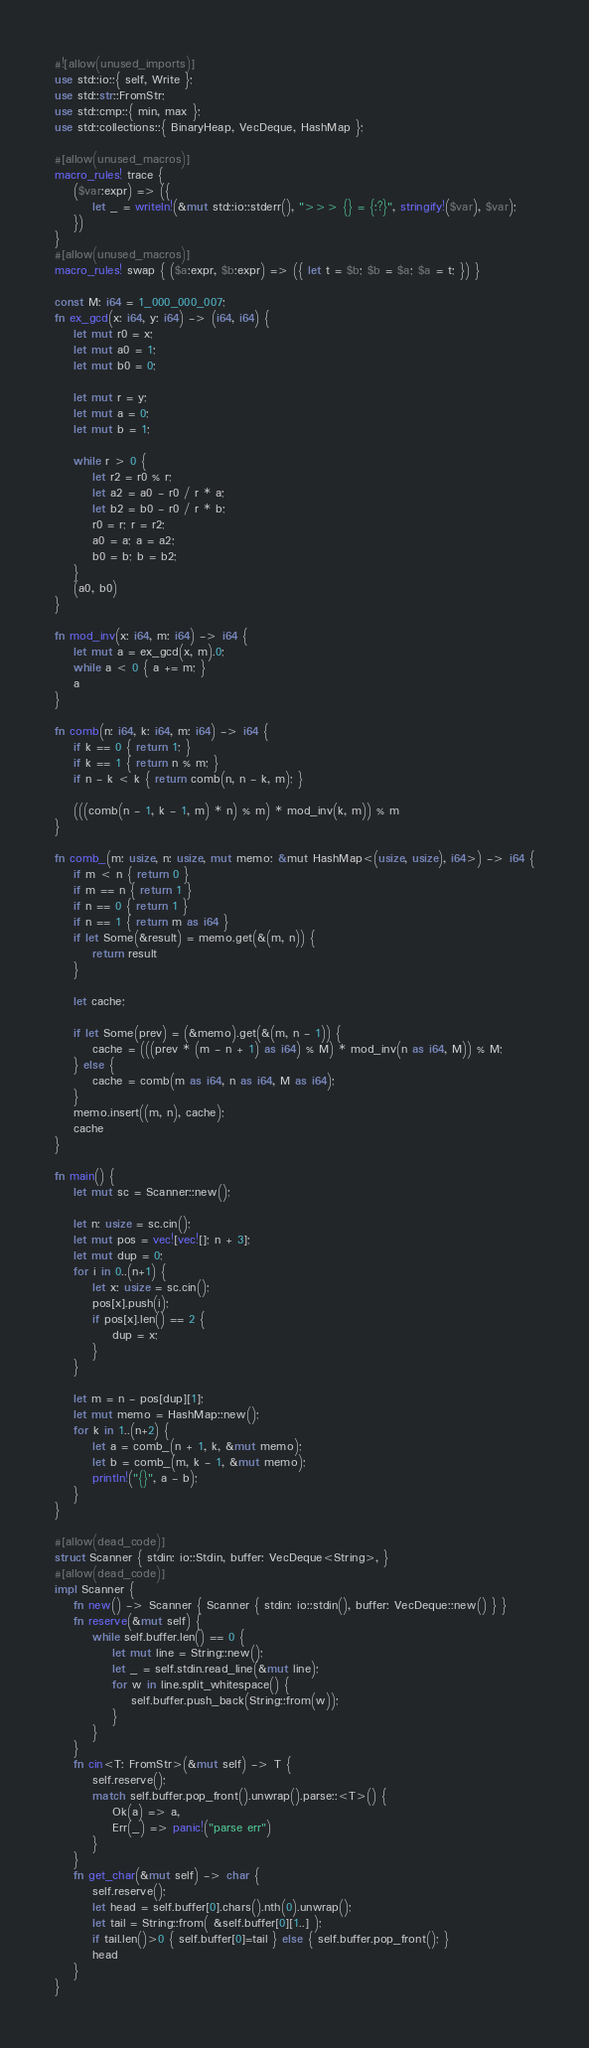Convert code to text. <code><loc_0><loc_0><loc_500><loc_500><_Rust_>#![allow(unused_imports)]
use std::io::{ self, Write };
use std::str::FromStr;
use std::cmp::{ min, max };
use std::collections::{ BinaryHeap, VecDeque, HashMap };

#[allow(unused_macros)]
macro_rules! trace {
    ($var:expr) => ({
        let _ = writeln!(&mut std::io::stderr(), ">>> {} = {:?}", stringify!($var), $var);
    })
}
#[allow(unused_macros)]
macro_rules! swap { ($a:expr, $b:expr) => ({ let t = $b; $b = $a; $a = t; }) }

const M: i64 = 1_000_000_007;
fn ex_gcd(x: i64, y: i64) -> (i64, i64) {
    let mut r0 = x;
    let mut a0 = 1;
    let mut b0 = 0;

    let mut r = y;
    let mut a = 0;
    let mut b = 1;

    while r > 0 {
        let r2 = r0 % r;
        let a2 = a0 - r0 / r * a;
        let b2 = b0 - r0 / r * b;
        r0 = r; r = r2;
        a0 = a; a = a2;
        b0 = b; b = b2;
    }
    (a0, b0)
}

fn mod_inv(x: i64, m: i64) -> i64 {
    let mut a = ex_gcd(x, m).0;
    while a < 0 { a += m; }
    a
}

fn comb(n: i64, k: i64, m: i64) -> i64 {
    if k == 0 { return 1; }
    if k == 1 { return n % m; }
    if n - k < k { return comb(n, n - k, m); }

    (((comb(n - 1, k - 1, m) * n) % m) * mod_inv(k, m)) % m
}

fn comb_(m: usize, n: usize, mut memo: &mut HashMap<(usize, usize), i64>) -> i64 {
    if m < n { return 0 }
    if m == n { return 1 }
    if n == 0 { return 1 }
    if n == 1 { return m as i64 }
    if let Some(&result) = memo.get(&(m, n)) {
        return result
    }

    let cache;

    if let Some(prev) = (&memo).get(&(m, n - 1)) {
        cache = (((prev * (m - n + 1) as i64) % M) * mod_inv(n as i64, M)) % M;
    } else {
        cache = comb(m as i64, n as i64, M as i64);
    }
    memo.insert((m, n), cache);
    cache
}

fn main() {
    let mut sc = Scanner::new();

    let n: usize = sc.cin();
    let mut pos = vec![vec![]; n + 3];
    let mut dup = 0;
    for i in 0..(n+1) {
        let x: usize = sc.cin();
        pos[x].push(i);
        if pos[x].len() == 2 {
            dup = x;
        }
    }

    let m = n - pos[dup][1];
    let mut memo = HashMap::new();
    for k in 1..(n+2) {
        let a = comb_(n + 1, k, &mut memo);
        let b = comb_(m, k - 1, &mut memo);
        println!("{}", a - b);
    }
}

#[allow(dead_code)]
struct Scanner { stdin: io::Stdin, buffer: VecDeque<String>, }
#[allow(dead_code)]
impl Scanner {
    fn new() -> Scanner { Scanner { stdin: io::stdin(), buffer: VecDeque::new() } }
    fn reserve(&mut self) {
        while self.buffer.len() == 0 {
            let mut line = String::new();
            let _ = self.stdin.read_line(&mut line);
            for w in line.split_whitespace() {
                self.buffer.push_back(String::from(w));
            }
        }
    }
    fn cin<T: FromStr>(&mut self) -> T {
        self.reserve();
        match self.buffer.pop_front().unwrap().parse::<T>() {
            Ok(a) => a,
            Err(_) => panic!("parse err")
        }
    }
    fn get_char(&mut self) -> char {
        self.reserve();
        let head = self.buffer[0].chars().nth(0).unwrap();
        let tail = String::from( &self.buffer[0][1..] );
        if tail.len()>0 { self.buffer[0]=tail } else { self.buffer.pop_front(); }
        head
    }
}
</code> 